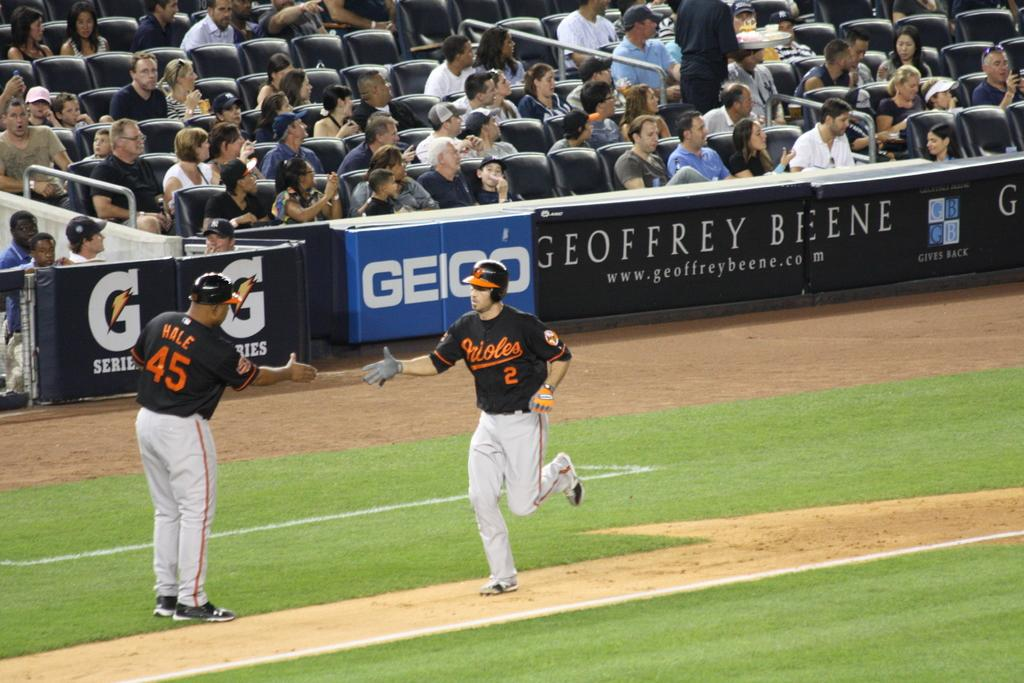<image>
Create a compact narrative representing the image presented. An Orioles player named Hale reaches out to shake the hand of a fellow player as he runs the bases. 